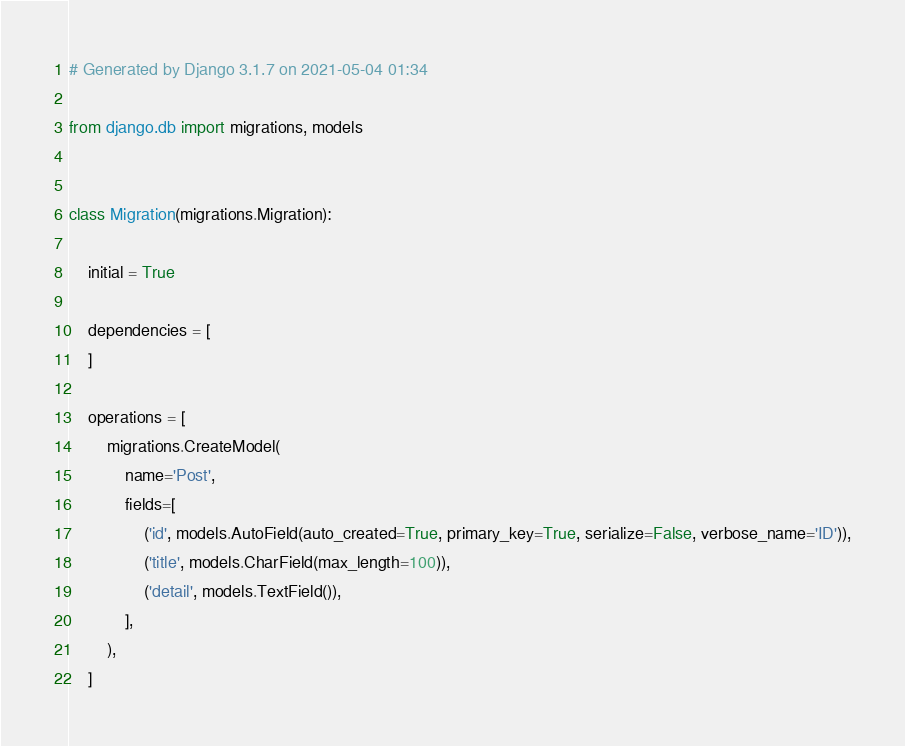<code> <loc_0><loc_0><loc_500><loc_500><_Python_># Generated by Django 3.1.7 on 2021-05-04 01:34

from django.db import migrations, models


class Migration(migrations.Migration):

    initial = True

    dependencies = [
    ]

    operations = [
        migrations.CreateModel(
            name='Post',
            fields=[
                ('id', models.AutoField(auto_created=True, primary_key=True, serialize=False, verbose_name='ID')),
                ('title', models.CharField(max_length=100)),
                ('detail', models.TextField()),
            ],
        ),
    ]
</code> 